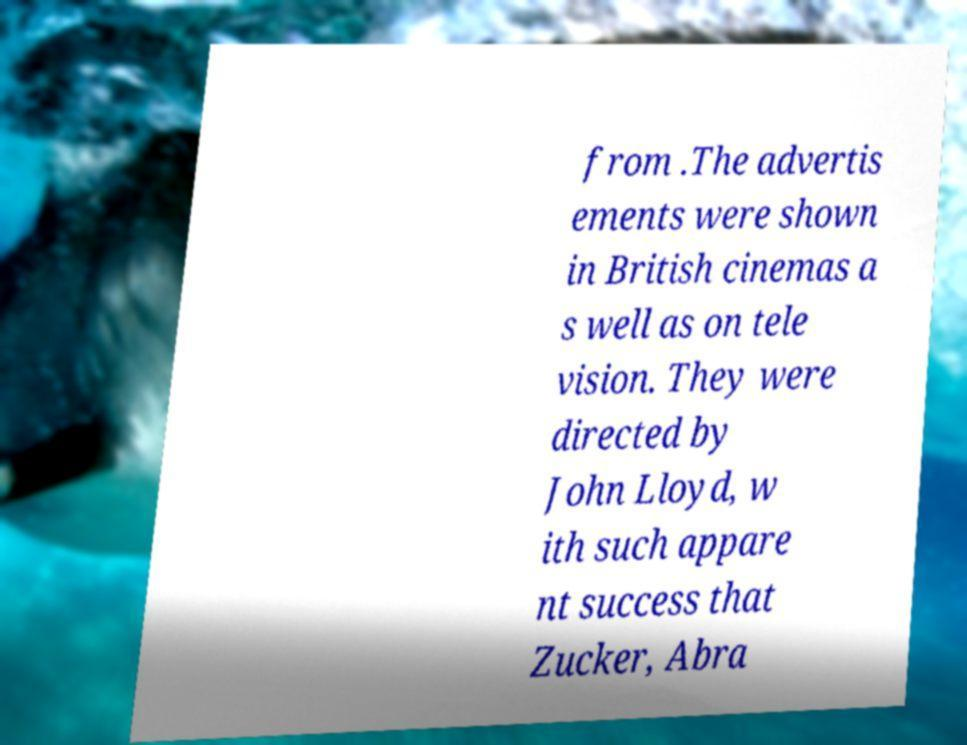Can you read and provide the text displayed in the image?This photo seems to have some interesting text. Can you extract and type it out for me? from .The advertis ements were shown in British cinemas a s well as on tele vision. They were directed by John Lloyd, w ith such appare nt success that Zucker, Abra 